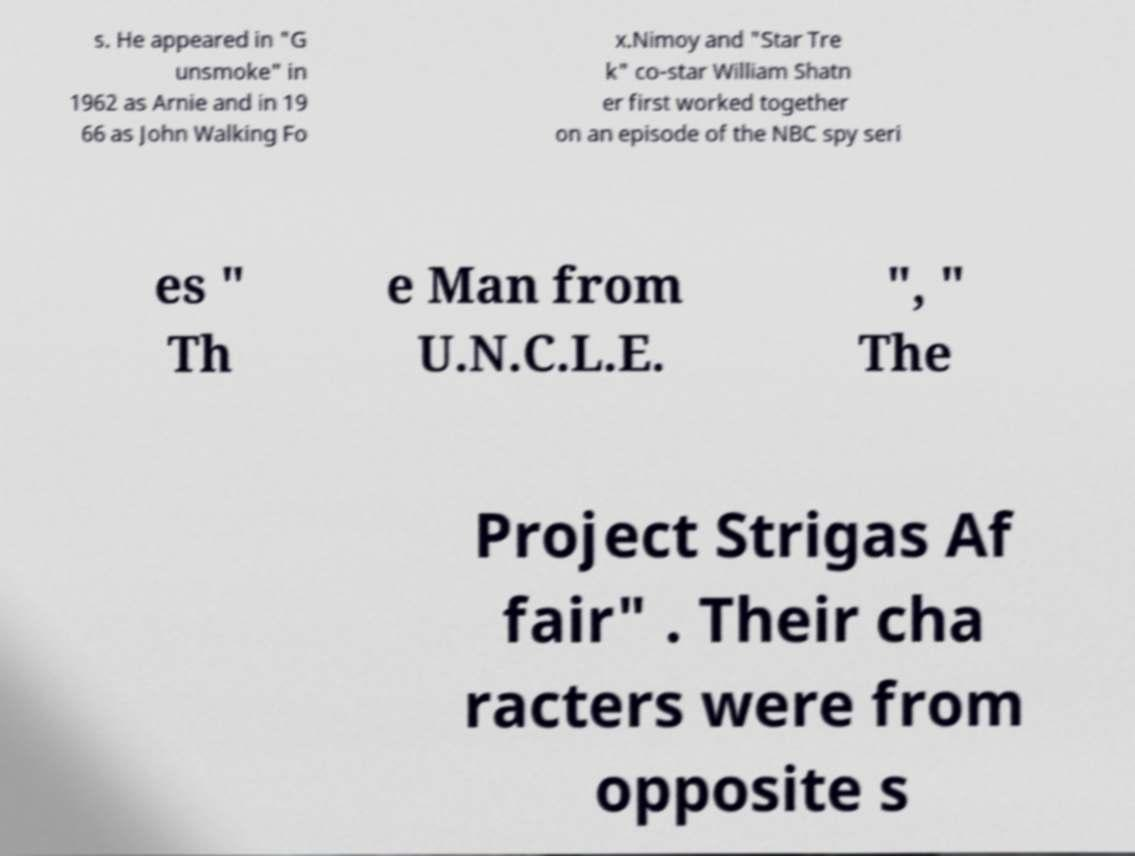What messages or text are displayed in this image? I need them in a readable, typed format. s. He appeared in "G unsmoke" in 1962 as Arnie and in 19 66 as John Walking Fo x.Nimoy and "Star Tre k" co-star William Shatn er first worked together on an episode of the NBC spy seri es " Th e Man from U.N.C.L.E. ", " The Project Strigas Af fair" . Their cha racters were from opposite s 